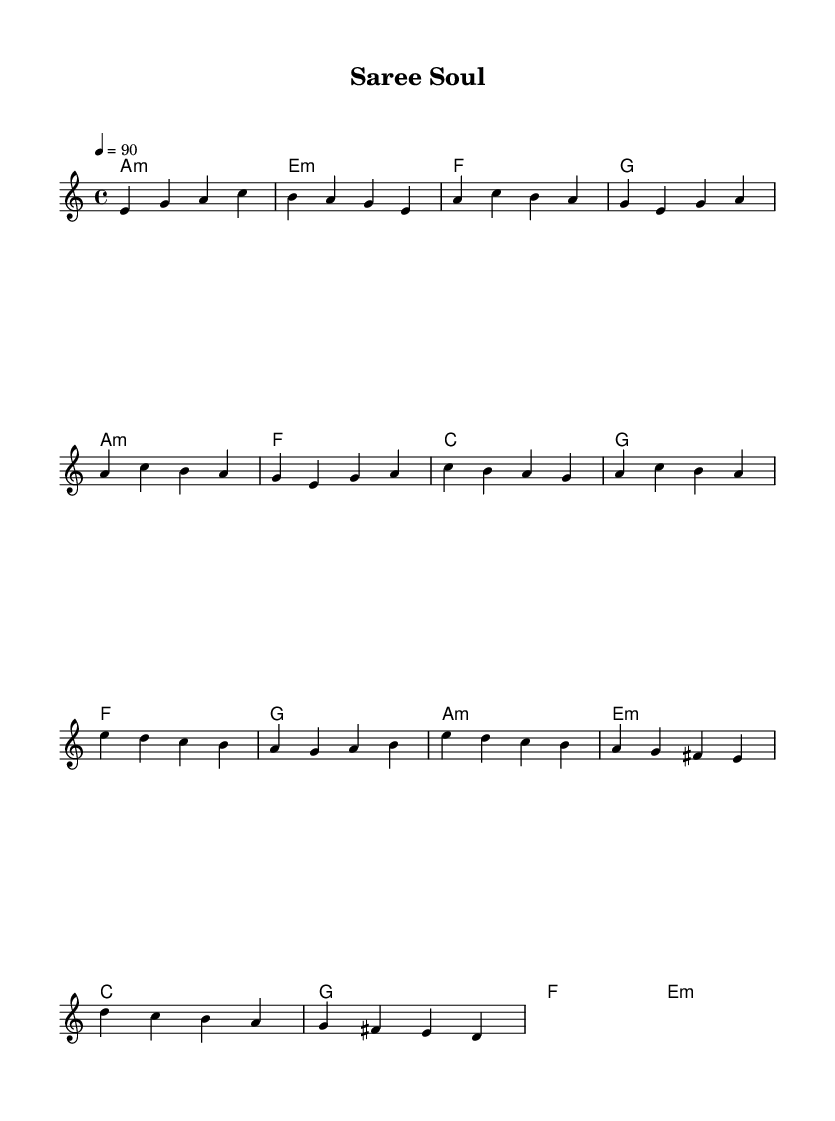What is the key signature of this music? The key signature indicated is A minor, which has no sharps or flats. A minor is the relative minor of C major.
Answer: A minor What is the time signature of this music? The time signature shown is 4/4, which means there are four beats in each measure and a quarter note gets one beat.
Answer: 4/4 What is the tempo of this piece? The tempo marking indicates a speed of 90 beats per minute, which sets the pace for the performance of the piece.
Answer: 90 How many measures are in the verse section? The verse section consists of two repeated phrases, each with four measures, totaling eight measures in the verse.
Answer: 8 What are the first four notes of the melody? The first four notes of the melody are E, G, A, and C, forming the introduction before proceeding to the verse.
Answer: E, G, A, C Which chord corresponds to the first measure? The first measure has the A minor chord indicated, establishing the tonality for the introduction of the piece.
Answer: A minor What unique feature reflects the influence of Indian classical music in this soul piece? The use of Indian classical rhythms and motifs can be inferred from the structure of the melody and the way it interacts with the harmony, highlighting a blend of both styles.
Answer: Indian rhythms and motifs 